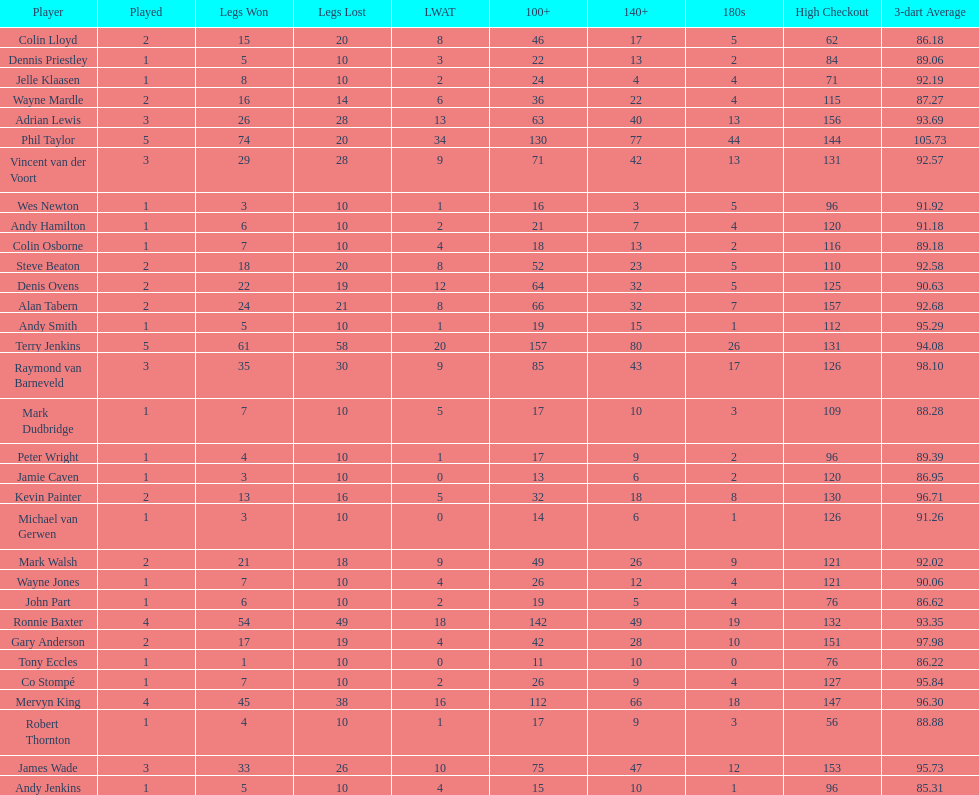What are the number of legs lost by james wade? 26. 